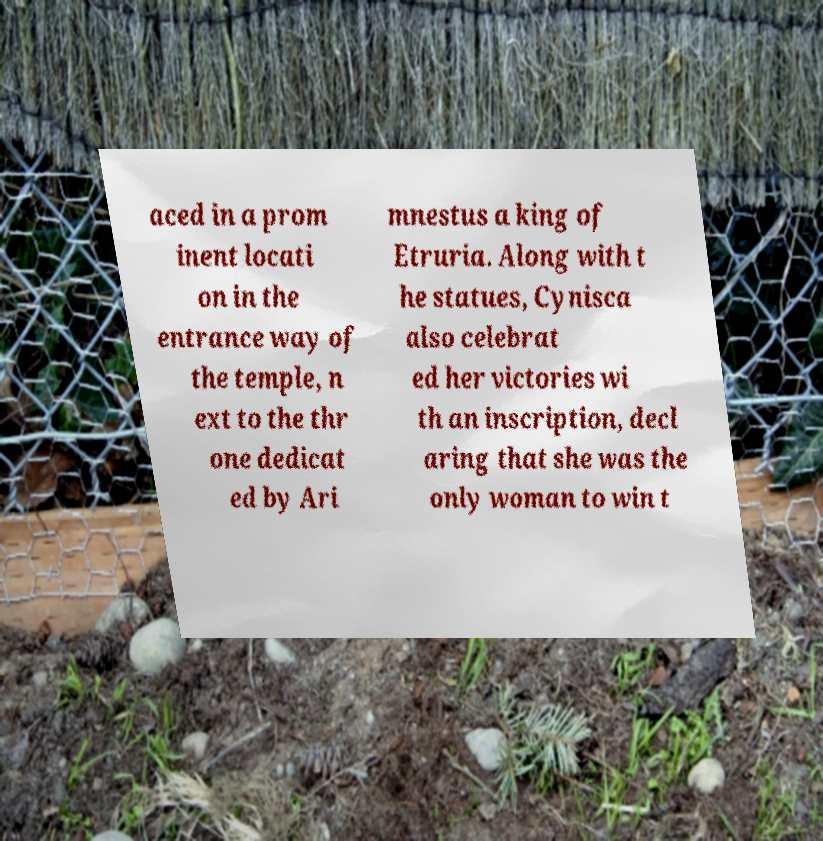I need the written content from this picture converted into text. Can you do that? aced in a prom inent locati on in the entrance way of the temple, n ext to the thr one dedicat ed by Ari mnestus a king of Etruria. Along with t he statues, Cynisca also celebrat ed her victories wi th an inscription, decl aring that she was the only woman to win t 